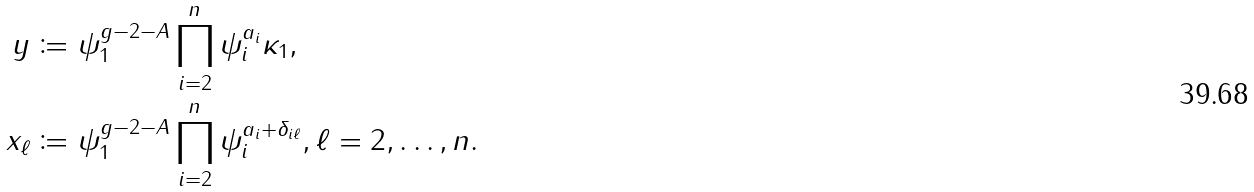<formula> <loc_0><loc_0><loc_500><loc_500>y & \coloneqq \psi _ { 1 } ^ { g - 2 - A } \prod _ { i = 2 } ^ { n } \psi _ { i } ^ { a _ { i } } \kappa _ { 1 } , \\ x _ { \ell } & \coloneqq \psi _ { 1 } ^ { g - 2 - A } \prod _ { i = 2 } ^ { n } \psi _ { i } ^ { a _ { i } + \delta _ { i \ell } } , \ell = 2 , \dots , n .</formula> 